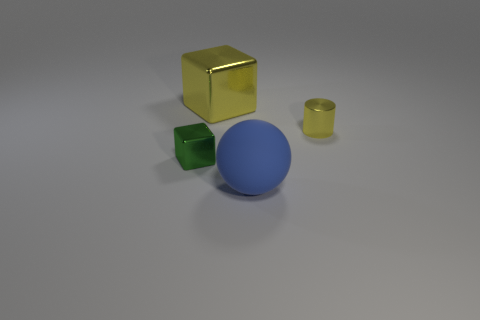Add 1 green objects. How many objects exist? 5 Subtract all cylinders. How many objects are left? 3 Add 4 metallic cubes. How many metallic cubes are left? 6 Add 2 green metallic cubes. How many green metallic cubes exist? 3 Subtract 0 blue cylinders. How many objects are left? 4 Subtract all large blue objects. Subtract all purple matte spheres. How many objects are left? 3 